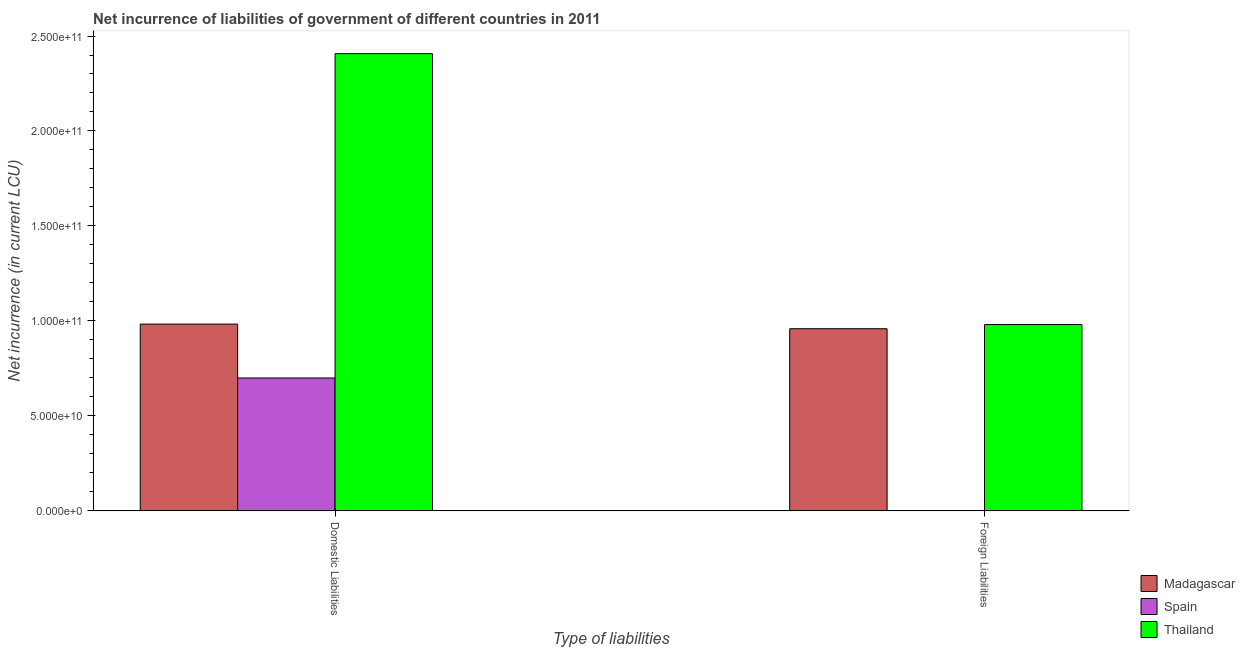How many groups of bars are there?
Your answer should be very brief. 2. Are the number of bars per tick equal to the number of legend labels?
Offer a terse response. No. Are the number of bars on each tick of the X-axis equal?
Your response must be concise. No. How many bars are there on the 1st tick from the right?
Provide a succinct answer. 2. What is the label of the 2nd group of bars from the left?
Offer a very short reply. Foreign Liabilities. What is the net incurrence of domestic liabilities in Thailand?
Ensure brevity in your answer.  2.41e+11. Across all countries, what is the maximum net incurrence of domestic liabilities?
Make the answer very short. 2.41e+11. Across all countries, what is the minimum net incurrence of foreign liabilities?
Keep it short and to the point. 0. In which country was the net incurrence of domestic liabilities maximum?
Ensure brevity in your answer.  Thailand. What is the total net incurrence of domestic liabilities in the graph?
Your response must be concise. 4.09e+11. What is the difference between the net incurrence of domestic liabilities in Thailand and that in Madagascar?
Provide a short and direct response. 1.42e+11. What is the difference between the net incurrence of foreign liabilities in Spain and the net incurrence of domestic liabilities in Thailand?
Your answer should be compact. -2.41e+11. What is the average net incurrence of foreign liabilities per country?
Give a very brief answer. 6.47e+1. What is the difference between the net incurrence of foreign liabilities and net incurrence of domestic liabilities in Thailand?
Offer a very short reply. -1.43e+11. What is the ratio of the net incurrence of domestic liabilities in Spain to that in Thailand?
Your answer should be compact. 0.29. Is the net incurrence of domestic liabilities in Spain less than that in Thailand?
Give a very brief answer. Yes. How many bars are there?
Keep it short and to the point. 5. Are the values on the major ticks of Y-axis written in scientific E-notation?
Give a very brief answer. Yes. Does the graph contain any zero values?
Your response must be concise. Yes. Does the graph contain grids?
Ensure brevity in your answer.  No. Where does the legend appear in the graph?
Give a very brief answer. Bottom right. What is the title of the graph?
Make the answer very short. Net incurrence of liabilities of government of different countries in 2011. What is the label or title of the X-axis?
Provide a short and direct response. Type of liabilities. What is the label or title of the Y-axis?
Give a very brief answer. Net incurrence (in current LCU). What is the Net incurrence (in current LCU) of Madagascar in Domestic Liabilities?
Provide a succinct answer. 9.83e+1. What is the Net incurrence (in current LCU) of Spain in Domestic Liabilities?
Make the answer very short. 7.00e+1. What is the Net incurrence (in current LCU) in Thailand in Domestic Liabilities?
Offer a terse response. 2.41e+11. What is the Net incurrence (in current LCU) of Madagascar in Foreign Liabilities?
Offer a terse response. 9.59e+1. What is the Net incurrence (in current LCU) of Thailand in Foreign Liabilities?
Offer a very short reply. 9.81e+1. Across all Type of liabilities, what is the maximum Net incurrence (in current LCU) in Madagascar?
Offer a terse response. 9.83e+1. Across all Type of liabilities, what is the maximum Net incurrence (in current LCU) of Spain?
Make the answer very short. 7.00e+1. Across all Type of liabilities, what is the maximum Net incurrence (in current LCU) in Thailand?
Your answer should be very brief. 2.41e+11. Across all Type of liabilities, what is the minimum Net incurrence (in current LCU) of Madagascar?
Your answer should be very brief. 9.59e+1. Across all Type of liabilities, what is the minimum Net incurrence (in current LCU) in Spain?
Provide a succinct answer. 0. Across all Type of liabilities, what is the minimum Net incurrence (in current LCU) of Thailand?
Your answer should be very brief. 9.81e+1. What is the total Net incurrence (in current LCU) in Madagascar in the graph?
Offer a terse response. 1.94e+11. What is the total Net incurrence (in current LCU) of Spain in the graph?
Offer a terse response. 7.00e+1. What is the total Net incurrence (in current LCU) in Thailand in the graph?
Provide a succinct answer. 3.39e+11. What is the difference between the Net incurrence (in current LCU) of Madagascar in Domestic Liabilities and that in Foreign Liabilities?
Your response must be concise. 2.43e+09. What is the difference between the Net incurrence (in current LCU) in Thailand in Domestic Liabilities and that in Foreign Liabilities?
Your response must be concise. 1.43e+11. What is the difference between the Net incurrence (in current LCU) of Madagascar in Domestic Liabilities and the Net incurrence (in current LCU) of Thailand in Foreign Liabilities?
Your response must be concise. 2.48e+08. What is the difference between the Net incurrence (in current LCU) of Spain in Domestic Liabilities and the Net incurrence (in current LCU) of Thailand in Foreign Liabilities?
Offer a terse response. -2.81e+1. What is the average Net incurrence (in current LCU) of Madagascar per Type of liabilities?
Keep it short and to the point. 9.71e+1. What is the average Net incurrence (in current LCU) in Spain per Type of liabilities?
Provide a succinct answer. 3.50e+1. What is the average Net incurrence (in current LCU) of Thailand per Type of liabilities?
Provide a succinct answer. 1.69e+11. What is the difference between the Net incurrence (in current LCU) of Madagascar and Net incurrence (in current LCU) of Spain in Domestic Liabilities?
Keep it short and to the point. 2.84e+1. What is the difference between the Net incurrence (in current LCU) of Madagascar and Net incurrence (in current LCU) of Thailand in Domestic Liabilities?
Provide a succinct answer. -1.42e+11. What is the difference between the Net incurrence (in current LCU) of Spain and Net incurrence (in current LCU) of Thailand in Domestic Liabilities?
Your response must be concise. -1.71e+11. What is the difference between the Net incurrence (in current LCU) in Madagascar and Net incurrence (in current LCU) in Thailand in Foreign Liabilities?
Provide a short and direct response. -2.18e+09. What is the ratio of the Net incurrence (in current LCU) in Madagascar in Domestic Liabilities to that in Foreign Liabilities?
Keep it short and to the point. 1.03. What is the ratio of the Net incurrence (in current LCU) of Thailand in Domestic Liabilities to that in Foreign Liabilities?
Your answer should be very brief. 2.45. What is the difference between the highest and the second highest Net incurrence (in current LCU) in Madagascar?
Ensure brevity in your answer.  2.43e+09. What is the difference between the highest and the second highest Net incurrence (in current LCU) of Thailand?
Provide a short and direct response. 1.43e+11. What is the difference between the highest and the lowest Net incurrence (in current LCU) of Madagascar?
Ensure brevity in your answer.  2.43e+09. What is the difference between the highest and the lowest Net incurrence (in current LCU) of Spain?
Provide a short and direct response. 7.00e+1. What is the difference between the highest and the lowest Net incurrence (in current LCU) in Thailand?
Keep it short and to the point. 1.43e+11. 